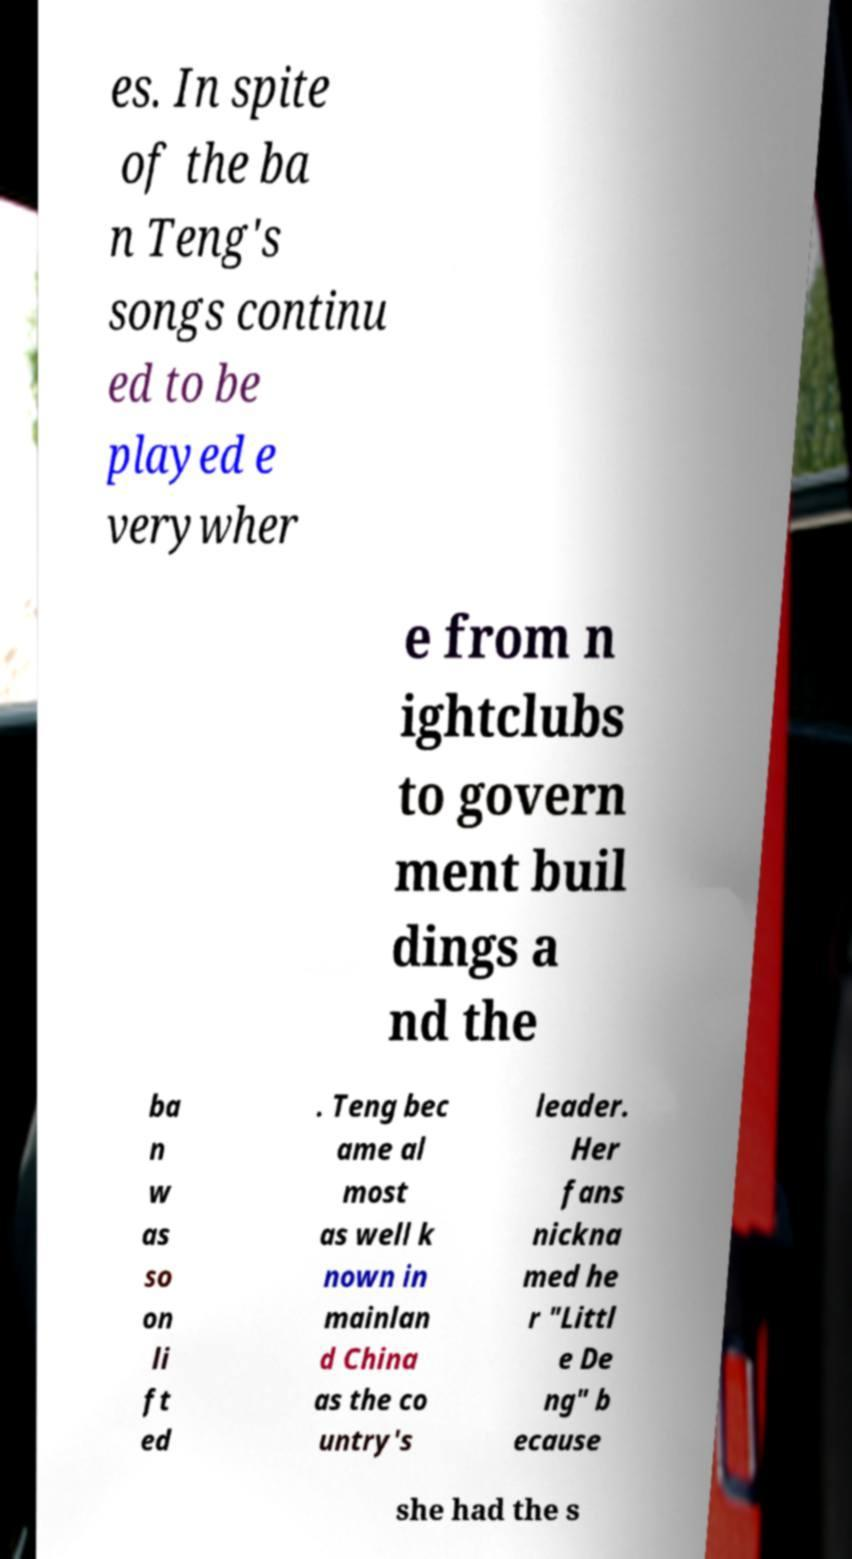Can you read and provide the text displayed in the image?This photo seems to have some interesting text. Can you extract and type it out for me? es. In spite of the ba n Teng's songs continu ed to be played e verywher e from n ightclubs to govern ment buil dings a nd the ba n w as so on li ft ed . Teng bec ame al most as well k nown in mainlan d China as the co untry's leader. Her fans nickna med he r "Littl e De ng" b ecause she had the s 